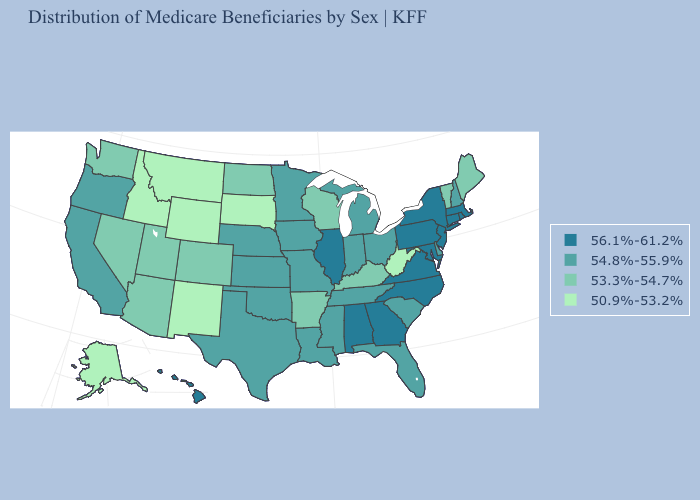Does the first symbol in the legend represent the smallest category?
Give a very brief answer. No. Does the first symbol in the legend represent the smallest category?
Concise answer only. No. What is the value of Minnesota?
Answer briefly. 54.8%-55.9%. Which states hav the highest value in the Northeast?
Answer briefly. Connecticut, Massachusetts, New Jersey, New York, Pennsylvania, Rhode Island. What is the highest value in the South ?
Answer briefly. 56.1%-61.2%. Which states hav the highest value in the West?
Write a very short answer. Hawaii. What is the value of Arkansas?
Keep it brief. 53.3%-54.7%. Among the states that border Kentucky , does West Virginia have the lowest value?
Write a very short answer. Yes. Does the map have missing data?
Answer briefly. No. What is the highest value in the USA?
Quick response, please. 56.1%-61.2%. What is the highest value in the USA?
Concise answer only. 56.1%-61.2%. Name the states that have a value in the range 53.3%-54.7%?
Write a very short answer. Arizona, Arkansas, Colorado, Kentucky, Maine, Nevada, North Dakota, Utah, Vermont, Washington, Wisconsin. Which states have the lowest value in the USA?
Short answer required. Alaska, Idaho, Montana, New Mexico, South Dakota, West Virginia, Wyoming. Name the states that have a value in the range 50.9%-53.2%?
Answer briefly. Alaska, Idaho, Montana, New Mexico, South Dakota, West Virginia, Wyoming. Name the states that have a value in the range 54.8%-55.9%?
Be succinct. California, Delaware, Florida, Indiana, Iowa, Kansas, Louisiana, Michigan, Minnesota, Mississippi, Missouri, Nebraska, New Hampshire, Ohio, Oklahoma, Oregon, South Carolina, Tennessee, Texas. 